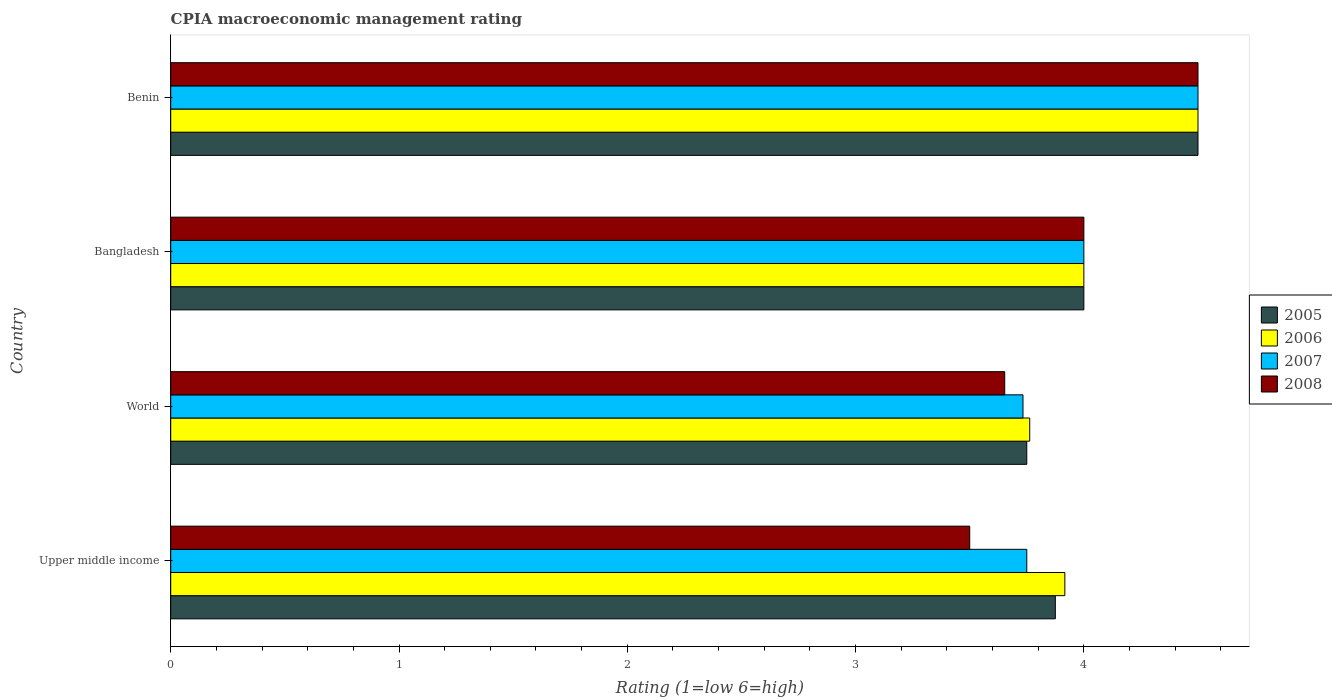How many groups of bars are there?
Your response must be concise. 4. How many bars are there on the 3rd tick from the top?
Offer a terse response. 4. What is the label of the 3rd group of bars from the top?
Ensure brevity in your answer.  World. In how many cases, is the number of bars for a given country not equal to the number of legend labels?
Provide a succinct answer. 0. What is the CPIA rating in 2007 in Upper middle income?
Provide a succinct answer. 3.75. In which country was the CPIA rating in 2005 maximum?
Your answer should be compact. Benin. What is the total CPIA rating in 2007 in the graph?
Offer a very short reply. 15.98. What is the difference between the CPIA rating in 2006 in Bangladesh and the CPIA rating in 2007 in World?
Provide a succinct answer. 0.27. What is the average CPIA rating in 2005 per country?
Your answer should be very brief. 4.03. What is the difference between the CPIA rating in 2007 and CPIA rating in 2006 in Benin?
Offer a terse response. 0. In how many countries, is the CPIA rating in 2006 greater than 4 ?
Your answer should be compact. 1. What is the ratio of the CPIA rating in 2005 in Upper middle income to that in World?
Offer a very short reply. 1.03. Is the CPIA rating in 2007 in Benin less than that in Upper middle income?
Your answer should be compact. No. In how many countries, is the CPIA rating in 2007 greater than the average CPIA rating in 2007 taken over all countries?
Provide a short and direct response. 2. Is the sum of the CPIA rating in 2008 in Benin and Upper middle income greater than the maximum CPIA rating in 2006 across all countries?
Your answer should be very brief. Yes. Is it the case that in every country, the sum of the CPIA rating in 2005 and CPIA rating in 2006 is greater than the sum of CPIA rating in 2008 and CPIA rating in 2007?
Make the answer very short. No. What does the 4th bar from the top in Benin represents?
Your answer should be very brief. 2005. What does the 2nd bar from the bottom in Bangladesh represents?
Your answer should be very brief. 2006. Are all the bars in the graph horizontal?
Offer a very short reply. Yes. Are the values on the major ticks of X-axis written in scientific E-notation?
Provide a short and direct response. No. How are the legend labels stacked?
Make the answer very short. Vertical. What is the title of the graph?
Your response must be concise. CPIA macroeconomic management rating. Does "1977" appear as one of the legend labels in the graph?
Keep it short and to the point. No. What is the Rating (1=low 6=high) of 2005 in Upper middle income?
Make the answer very short. 3.88. What is the Rating (1=low 6=high) of 2006 in Upper middle income?
Keep it short and to the point. 3.92. What is the Rating (1=low 6=high) in 2007 in Upper middle income?
Make the answer very short. 3.75. What is the Rating (1=low 6=high) in 2005 in World?
Your answer should be very brief. 3.75. What is the Rating (1=low 6=high) in 2006 in World?
Your answer should be compact. 3.76. What is the Rating (1=low 6=high) of 2007 in World?
Your answer should be very brief. 3.73. What is the Rating (1=low 6=high) in 2008 in World?
Ensure brevity in your answer.  3.65. What is the Rating (1=low 6=high) of 2006 in Bangladesh?
Your answer should be compact. 4. Across all countries, what is the maximum Rating (1=low 6=high) of 2005?
Your answer should be very brief. 4.5. Across all countries, what is the maximum Rating (1=low 6=high) of 2006?
Provide a succinct answer. 4.5. Across all countries, what is the maximum Rating (1=low 6=high) in 2007?
Give a very brief answer. 4.5. Across all countries, what is the minimum Rating (1=low 6=high) in 2005?
Provide a succinct answer. 3.75. Across all countries, what is the minimum Rating (1=low 6=high) of 2006?
Provide a short and direct response. 3.76. Across all countries, what is the minimum Rating (1=low 6=high) of 2007?
Your answer should be very brief. 3.73. Across all countries, what is the minimum Rating (1=low 6=high) of 2008?
Your response must be concise. 3.5. What is the total Rating (1=low 6=high) of 2005 in the graph?
Make the answer very short. 16.12. What is the total Rating (1=low 6=high) of 2006 in the graph?
Provide a succinct answer. 16.18. What is the total Rating (1=low 6=high) in 2007 in the graph?
Make the answer very short. 15.98. What is the total Rating (1=low 6=high) in 2008 in the graph?
Provide a succinct answer. 15.65. What is the difference between the Rating (1=low 6=high) of 2005 in Upper middle income and that in World?
Ensure brevity in your answer.  0.12. What is the difference between the Rating (1=low 6=high) in 2006 in Upper middle income and that in World?
Keep it short and to the point. 0.15. What is the difference between the Rating (1=low 6=high) of 2007 in Upper middle income and that in World?
Your answer should be very brief. 0.02. What is the difference between the Rating (1=low 6=high) in 2008 in Upper middle income and that in World?
Your response must be concise. -0.15. What is the difference between the Rating (1=low 6=high) of 2005 in Upper middle income and that in Bangladesh?
Give a very brief answer. -0.12. What is the difference between the Rating (1=low 6=high) of 2006 in Upper middle income and that in Bangladesh?
Keep it short and to the point. -0.08. What is the difference between the Rating (1=low 6=high) of 2007 in Upper middle income and that in Bangladesh?
Your response must be concise. -0.25. What is the difference between the Rating (1=low 6=high) in 2008 in Upper middle income and that in Bangladesh?
Your response must be concise. -0.5. What is the difference between the Rating (1=low 6=high) in 2005 in Upper middle income and that in Benin?
Offer a very short reply. -0.62. What is the difference between the Rating (1=low 6=high) of 2006 in Upper middle income and that in Benin?
Ensure brevity in your answer.  -0.58. What is the difference between the Rating (1=low 6=high) of 2007 in Upper middle income and that in Benin?
Provide a short and direct response. -0.75. What is the difference between the Rating (1=low 6=high) of 2005 in World and that in Bangladesh?
Offer a very short reply. -0.25. What is the difference between the Rating (1=low 6=high) of 2006 in World and that in Bangladesh?
Your response must be concise. -0.24. What is the difference between the Rating (1=low 6=high) of 2007 in World and that in Bangladesh?
Your answer should be compact. -0.27. What is the difference between the Rating (1=low 6=high) in 2008 in World and that in Bangladesh?
Your response must be concise. -0.35. What is the difference between the Rating (1=low 6=high) of 2005 in World and that in Benin?
Ensure brevity in your answer.  -0.75. What is the difference between the Rating (1=low 6=high) of 2006 in World and that in Benin?
Keep it short and to the point. -0.74. What is the difference between the Rating (1=low 6=high) of 2007 in World and that in Benin?
Your answer should be compact. -0.77. What is the difference between the Rating (1=low 6=high) of 2008 in World and that in Benin?
Provide a short and direct response. -0.85. What is the difference between the Rating (1=low 6=high) in 2005 in Bangladesh and that in Benin?
Make the answer very short. -0.5. What is the difference between the Rating (1=low 6=high) of 2007 in Bangladesh and that in Benin?
Make the answer very short. -0.5. What is the difference between the Rating (1=low 6=high) of 2008 in Bangladesh and that in Benin?
Keep it short and to the point. -0.5. What is the difference between the Rating (1=low 6=high) in 2005 in Upper middle income and the Rating (1=low 6=high) in 2006 in World?
Provide a succinct answer. 0.11. What is the difference between the Rating (1=low 6=high) in 2005 in Upper middle income and the Rating (1=low 6=high) in 2007 in World?
Ensure brevity in your answer.  0.14. What is the difference between the Rating (1=low 6=high) in 2005 in Upper middle income and the Rating (1=low 6=high) in 2008 in World?
Make the answer very short. 0.22. What is the difference between the Rating (1=low 6=high) of 2006 in Upper middle income and the Rating (1=low 6=high) of 2007 in World?
Ensure brevity in your answer.  0.18. What is the difference between the Rating (1=low 6=high) of 2006 in Upper middle income and the Rating (1=low 6=high) of 2008 in World?
Make the answer very short. 0.26. What is the difference between the Rating (1=low 6=high) in 2007 in Upper middle income and the Rating (1=low 6=high) in 2008 in World?
Provide a short and direct response. 0.1. What is the difference between the Rating (1=low 6=high) of 2005 in Upper middle income and the Rating (1=low 6=high) of 2006 in Bangladesh?
Make the answer very short. -0.12. What is the difference between the Rating (1=low 6=high) in 2005 in Upper middle income and the Rating (1=low 6=high) in 2007 in Bangladesh?
Keep it short and to the point. -0.12. What is the difference between the Rating (1=low 6=high) of 2005 in Upper middle income and the Rating (1=low 6=high) of 2008 in Bangladesh?
Provide a short and direct response. -0.12. What is the difference between the Rating (1=low 6=high) in 2006 in Upper middle income and the Rating (1=low 6=high) in 2007 in Bangladesh?
Your response must be concise. -0.08. What is the difference between the Rating (1=low 6=high) in 2006 in Upper middle income and the Rating (1=low 6=high) in 2008 in Bangladesh?
Keep it short and to the point. -0.08. What is the difference between the Rating (1=low 6=high) in 2007 in Upper middle income and the Rating (1=low 6=high) in 2008 in Bangladesh?
Make the answer very short. -0.25. What is the difference between the Rating (1=low 6=high) in 2005 in Upper middle income and the Rating (1=low 6=high) in 2006 in Benin?
Give a very brief answer. -0.62. What is the difference between the Rating (1=low 6=high) in 2005 in Upper middle income and the Rating (1=low 6=high) in 2007 in Benin?
Offer a terse response. -0.62. What is the difference between the Rating (1=low 6=high) in 2005 in Upper middle income and the Rating (1=low 6=high) in 2008 in Benin?
Make the answer very short. -0.62. What is the difference between the Rating (1=low 6=high) in 2006 in Upper middle income and the Rating (1=low 6=high) in 2007 in Benin?
Provide a short and direct response. -0.58. What is the difference between the Rating (1=low 6=high) of 2006 in Upper middle income and the Rating (1=low 6=high) of 2008 in Benin?
Make the answer very short. -0.58. What is the difference between the Rating (1=low 6=high) of 2007 in Upper middle income and the Rating (1=low 6=high) of 2008 in Benin?
Offer a terse response. -0.75. What is the difference between the Rating (1=low 6=high) in 2005 in World and the Rating (1=low 6=high) in 2006 in Bangladesh?
Provide a short and direct response. -0.25. What is the difference between the Rating (1=low 6=high) in 2006 in World and the Rating (1=low 6=high) in 2007 in Bangladesh?
Ensure brevity in your answer.  -0.24. What is the difference between the Rating (1=low 6=high) in 2006 in World and the Rating (1=low 6=high) in 2008 in Bangladesh?
Your answer should be compact. -0.24. What is the difference between the Rating (1=low 6=high) of 2007 in World and the Rating (1=low 6=high) of 2008 in Bangladesh?
Your answer should be compact. -0.27. What is the difference between the Rating (1=low 6=high) of 2005 in World and the Rating (1=low 6=high) of 2006 in Benin?
Ensure brevity in your answer.  -0.75. What is the difference between the Rating (1=low 6=high) in 2005 in World and the Rating (1=low 6=high) in 2007 in Benin?
Ensure brevity in your answer.  -0.75. What is the difference between the Rating (1=low 6=high) of 2005 in World and the Rating (1=low 6=high) of 2008 in Benin?
Your answer should be compact. -0.75. What is the difference between the Rating (1=low 6=high) of 2006 in World and the Rating (1=low 6=high) of 2007 in Benin?
Provide a short and direct response. -0.74. What is the difference between the Rating (1=low 6=high) of 2006 in World and the Rating (1=low 6=high) of 2008 in Benin?
Provide a short and direct response. -0.74. What is the difference between the Rating (1=low 6=high) of 2007 in World and the Rating (1=low 6=high) of 2008 in Benin?
Offer a terse response. -0.77. What is the difference between the Rating (1=low 6=high) of 2005 in Bangladesh and the Rating (1=low 6=high) of 2006 in Benin?
Provide a short and direct response. -0.5. What is the difference between the Rating (1=low 6=high) in 2005 in Bangladesh and the Rating (1=low 6=high) in 2008 in Benin?
Keep it short and to the point. -0.5. What is the difference between the Rating (1=low 6=high) of 2006 in Bangladesh and the Rating (1=low 6=high) of 2007 in Benin?
Provide a short and direct response. -0.5. What is the difference between the Rating (1=low 6=high) of 2006 in Bangladesh and the Rating (1=low 6=high) of 2008 in Benin?
Make the answer very short. -0.5. What is the difference between the Rating (1=low 6=high) of 2007 in Bangladesh and the Rating (1=low 6=high) of 2008 in Benin?
Ensure brevity in your answer.  -0.5. What is the average Rating (1=low 6=high) in 2005 per country?
Offer a terse response. 4.03. What is the average Rating (1=low 6=high) of 2006 per country?
Provide a short and direct response. 4.04. What is the average Rating (1=low 6=high) in 2007 per country?
Your answer should be very brief. 4. What is the average Rating (1=low 6=high) in 2008 per country?
Ensure brevity in your answer.  3.91. What is the difference between the Rating (1=low 6=high) of 2005 and Rating (1=low 6=high) of 2006 in Upper middle income?
Offer a very short reply. -0.04. What is the difference between the Rating (1=low 6=high) in 2005 and Rating (1=low 6=high) in 2007 in Upper middle income?
Offer a very short reply. 0.12. What is the difference between the Rating (1=low 6=high) of 2005 and Rating (1=low 6=high) of 2008 in Upper middle income?
Your response must be concise. 0.38. What is the difference between the Rating (1=low 6=high) in 2006 and Rating (1=low 6=high) in 2008 in Upper middle income?
Offer a very short reply. 0.42. What is the difference between the Rating (1=low 6=high) of 2005 and Rating (1=low 6=high) of 2006 in World?
Provide a short and direct response. -0.01. What is the difference between the Rating (1=low 6=high) of 2005 and Rating (1=low 6=high) of 2007 in World?
Offer a very short reply. 0.02. What is the difference between the Rating (1=low 6=high) in 2005 and Rating (1=low 6=high) in 2008 in World?
Your answer should be very brief. 0.1. What is the difference between the Rating (1=low 6=high) of 2006 and Rating (1=low 6=high) of 2007 in World?
Your answer should be very brief. 0.03. What is the difference between the Rating (1=low 6=high) in 2006 and Rating (1=low 6=high) in 2008 in World?
Give a very brief answer. 0.11. What is the difference between the Rating (1=low 6=high) in 2005 and Rating (1=low 6=high) in 2006 in Bangladesh?
Give a very brief answer. 0. What is the difference between the Rating (1=low 6=high) in 2005 and Rating (1=low 6=high) in 2007 in Bangladesh?
Ensure brevity in your answer.  0. What is the difference between the Rating (1=low 6=high) of 2005 and Rating (1=low 6=high) of 2008 in Bangladesh?
Provide a short and direct response. 0. What is the difference between the Rating (1=low 6=high) in 2006 and Rating (1=low 6=high) in 2008 in Benin?
Your answer should be very brief. 0. What is the ratio of the Rating (1=low 6=high) in 2005 in Upper middle income to that in World?
Your response must be concise. 1.03. What is the ratio of the Rating (1=low 6=high) of 2006 in Upper middle income to that in World?
Your answer should be compact. 1.04. What is the ratio of the Rating (1=low 6=high) in 2007 in Upper middle income to that in World?
Ensure brevity in your answer.  1. What is the ratio of the Rating (1=low 6=high) in 2008 in Upper middle income to that in World?
Your answer should be compact. 0.96. What is the ratio of the Rating (1=low 6=high) of 2005 in Upper middle income to that in Bangladesh?
Your answer should be compact. 0.97. What is the ratio of the Rating (1=low 6=high) in 2006 in Upper middle income to that in Bangladesh?
Your answer should be very brief. 0.98. What is the ratio of the Rating (1=low 6=high) of 2005 in Upper middle income to that in Benin?
Ensure brevity in your answer.  0.86. What is the ratio of the Rating (1=low 6=high) in 2006 in Upper middle income to that in Benin?
Offer a very short reply. 0.87. What is the ratio of the Rating (1=low 6=high) of 2005 in World to that in Bangladesh?
Your response must be concise. 0.94. What is the ratio of the Rating (1=low 6=high) in 2006 in World to that in Bangladesh?
Keep it short and to the point. 0.94. What is the ratio of the Rating (1=low 6=high) in 2007 in World to that in Bangladesh?
Keep it short and to the point. 0.93. What is the ratio of the Rating (1=low 6=high) of 2008 in World to that in Bangladesh?
Keep it short and to the point. 0.91. What is the ratio of the Rating (1=low 6=high) of 2006 in World to that in Benin?
Ensure brevity in your answer.  0.84. What is the ratio of the Rating (1=low 6=high) in 2007 in World to that in Benin?
Ensure brevity in your answer.  0.83. What is the ratio of the Rating (1=low 6=high) in 2008 in World to that in Benin?
Provide a succinct answer. 0.81. What is the ratio of the Rating (1=low 6=high) of 2005 in Bangladesh to that in Benin?
Your answer should be very brief. 0.89. What is the ratio of the Rating (1=low 6=high) in 2006 in Bangladesh to that in Benin?
Make the answer very short. 0.89. What is the ratio of the Rating (1=low 6=high) in 2008 in Bangladesh to that in Benin?
Provide a succinct answer. 0.89. What is the difference between the highest and the second highest Rating (1=low 6=high) of 2005?
Provide a succinct answer. 0.5. What is the difference between the highest and the second highest Rating (1=low 6=high) of 2008?
Offer a terse response. 0.5. What is the difference between the highest and the lowest Rating (1=low 6=high) in 2005?
Provide a short and direct response. 0.75. What is the difference between the highest and the lowest Rating (1=low 6=high) in 2006?
Your response must be concise. 0.74. What is the difference between the highest and the lowest Rating (1=low 6=high) of 2007?
Make the answer very short. 0.77. 